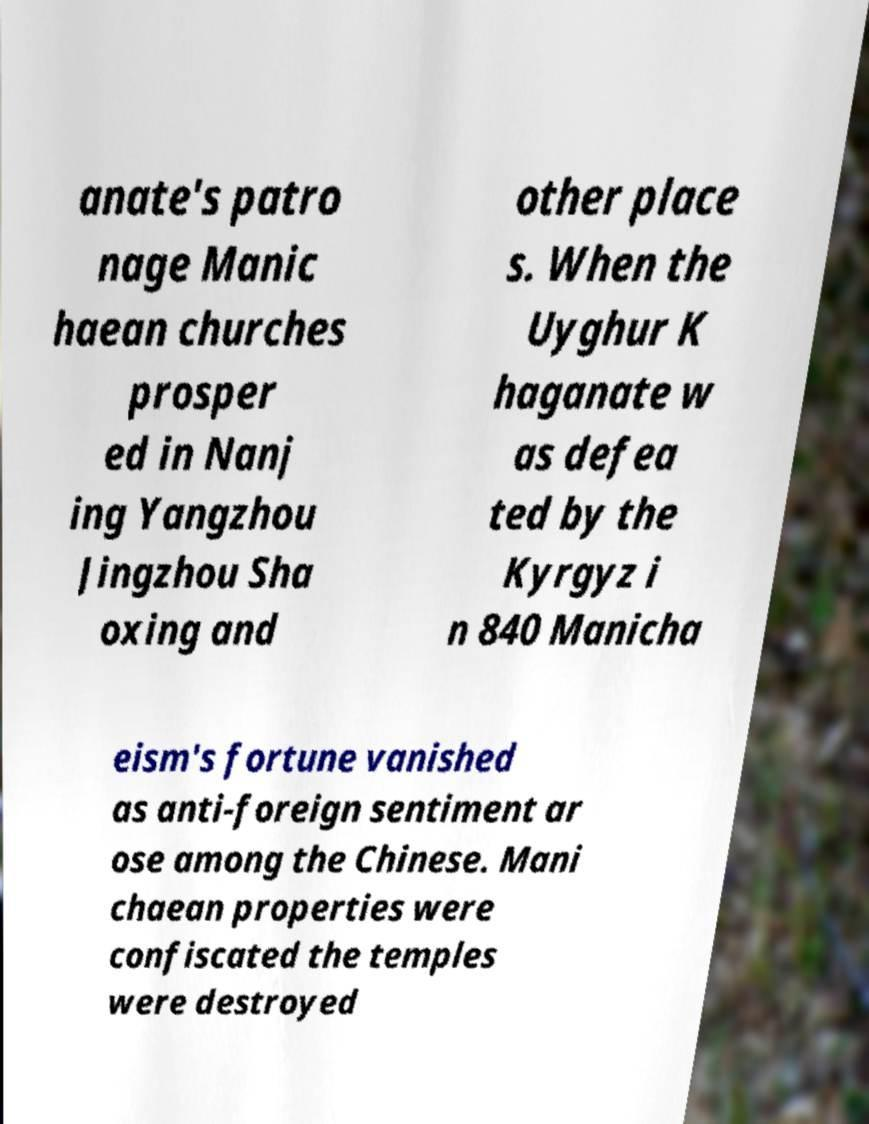Could you assist in decoding the text presented in this image and type it out clearly? anate's patro nage Manic haean churches prosper ed in Nanj ing Yangzhou Jingzhou Sha oxing and other place s. When the Uyghur K haganate w as defea ted by the Kyrgyz i n 840 Manicha eism's fortune vanished as anti-foreign sentiment ar ose among the Chinese. Mani chaean properties were confiscated the temples were destroyed 